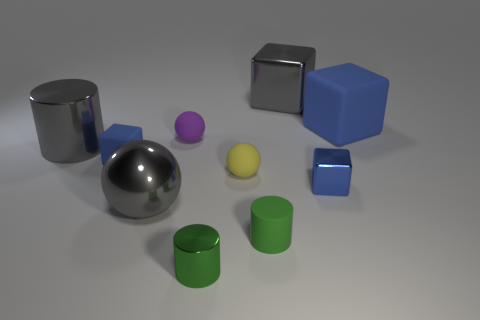Subtract all shiny cylinders. How many cylinders are left? 1 Subtract 1 cubes. How many cubes are left? 3 Subtract all cyan cylinders. How many blue cubes are left? 3 Subtract all gray cylinders. How many cylinders are left? 2 Subtract all red cylinders. Subtract all yellow cubes. How many cylinders are left? 3 Subtract all small shiny cylinders. Subtract all small yellow spheres. How many objects are left? 8 Add 8 tiny metal things. How many tiny metal things are left? 10 Add 1 large brown things. How many large brown things exist? 1 Subtract 0 cyan cylinders. How many objects are left? 10 Subtract all cubes. How many objects are left? 6 